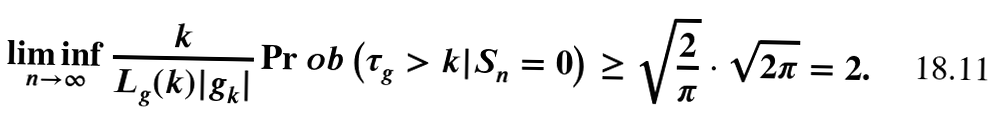<formula> <loc_0><loc_0><loc_500><loc_500>\liminf _ { n \rightarrow \infty } \frac { k } { L _ { g } ( k ) | g _ { k } | } \Pr o b \left ( \tau _ { g } > k | S _ { n } = 0 \right ) \geq \sqrt { \frac { 2 } { \pi } } \cdot \sqrt { 2 \pi } = 2 .</formula> 